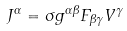Convert formula to latex. <formula><loc_0><loc_0><loc_500><loc_500>J ^ { \alpha } = { \sigma } g ^ { \alpha \beta } F _ { \beta \gamma } V ^ { \gamma }</formula> 